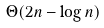<formula> <loc_0><loc_0><loc_500><loc_500>\Theta ( 2 n - \log n )</formula> 